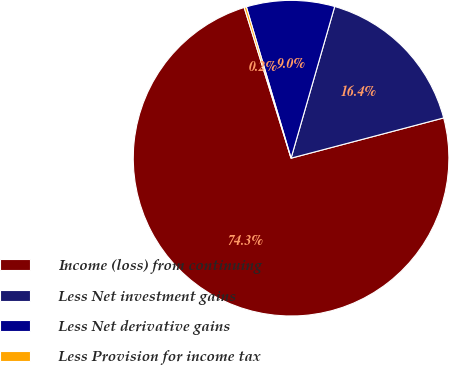<chart> <loc_0><loc_0><loc_500><loc_500><pie_chart><fcel>Income (loss) from continuing<fcel>Less Net investment gains<fcel>Less Net derivative gains<fcel>Less Provision for income tax<nl><fcel>74.31%<fcel>16.44%<fcel>9.03%<fcel>0.23%<nl></chart> 